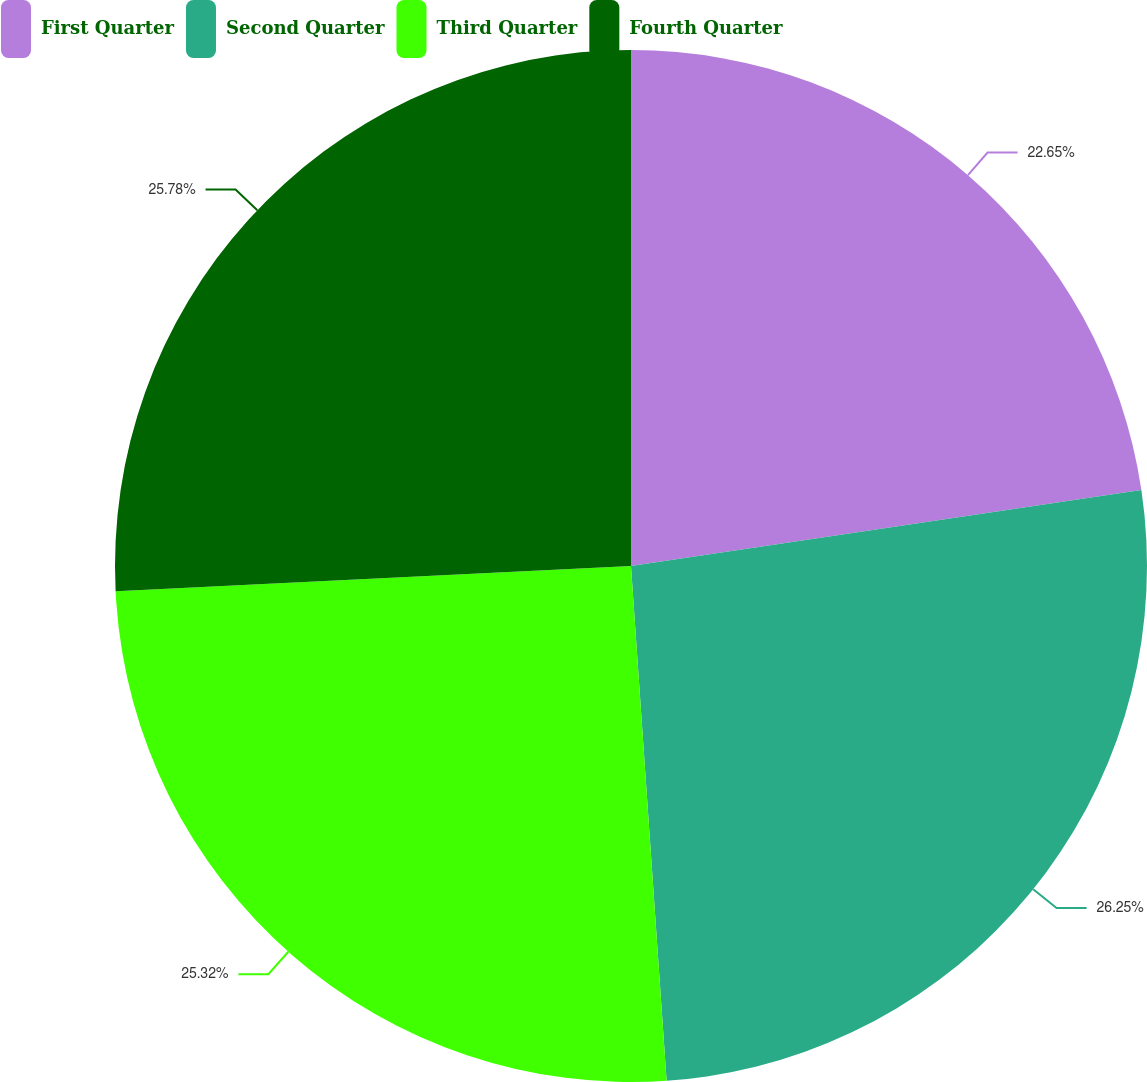Convert chart. <chart><loc_0><loc_0><loc_500><loc_500><pie_chart><fcel>First Quarter<fcel>Second Quarter<fcel>Third Quarter<fcel>Fourth Quarter<nl><fcel>22.65%<fcel>26.25%<fcel>25.32%<fcel>25.78%<nl></chart> 